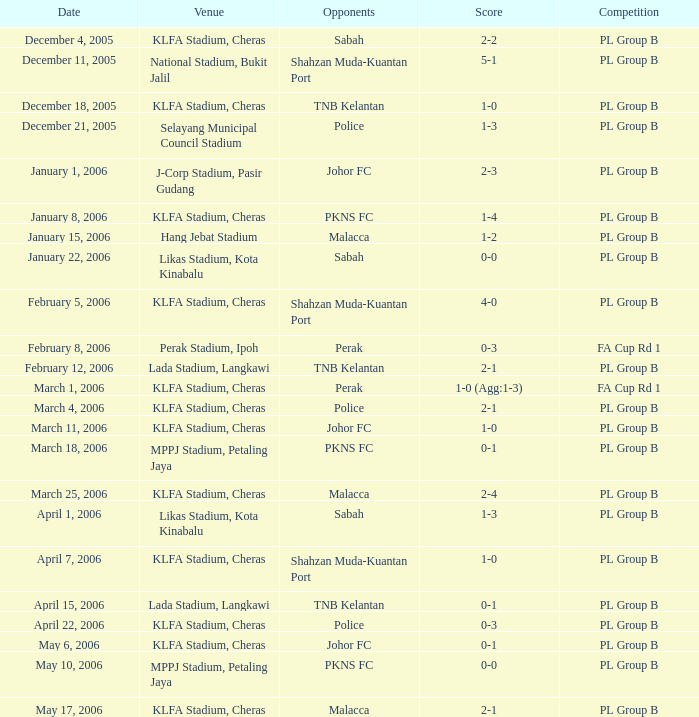Which event has competitors of pkns fc, and a tally of 0-0? PL Group B. 